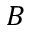<formula> <loc_0><loc_0><loc_500><loc_500>B</formula> 